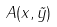<formula> <loc_0><loc_0><loc_500><loc_500>A ( x , \vec { y } )</formula> 